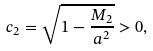Convert formula to latex. <formula><loc_0><loc_0><loc_500><loc_500>c _ { 2 } = \sqrt { 1 - \frac { M _ { 2 } } { a ^ { 2 } } } > 0 ,</formula> 